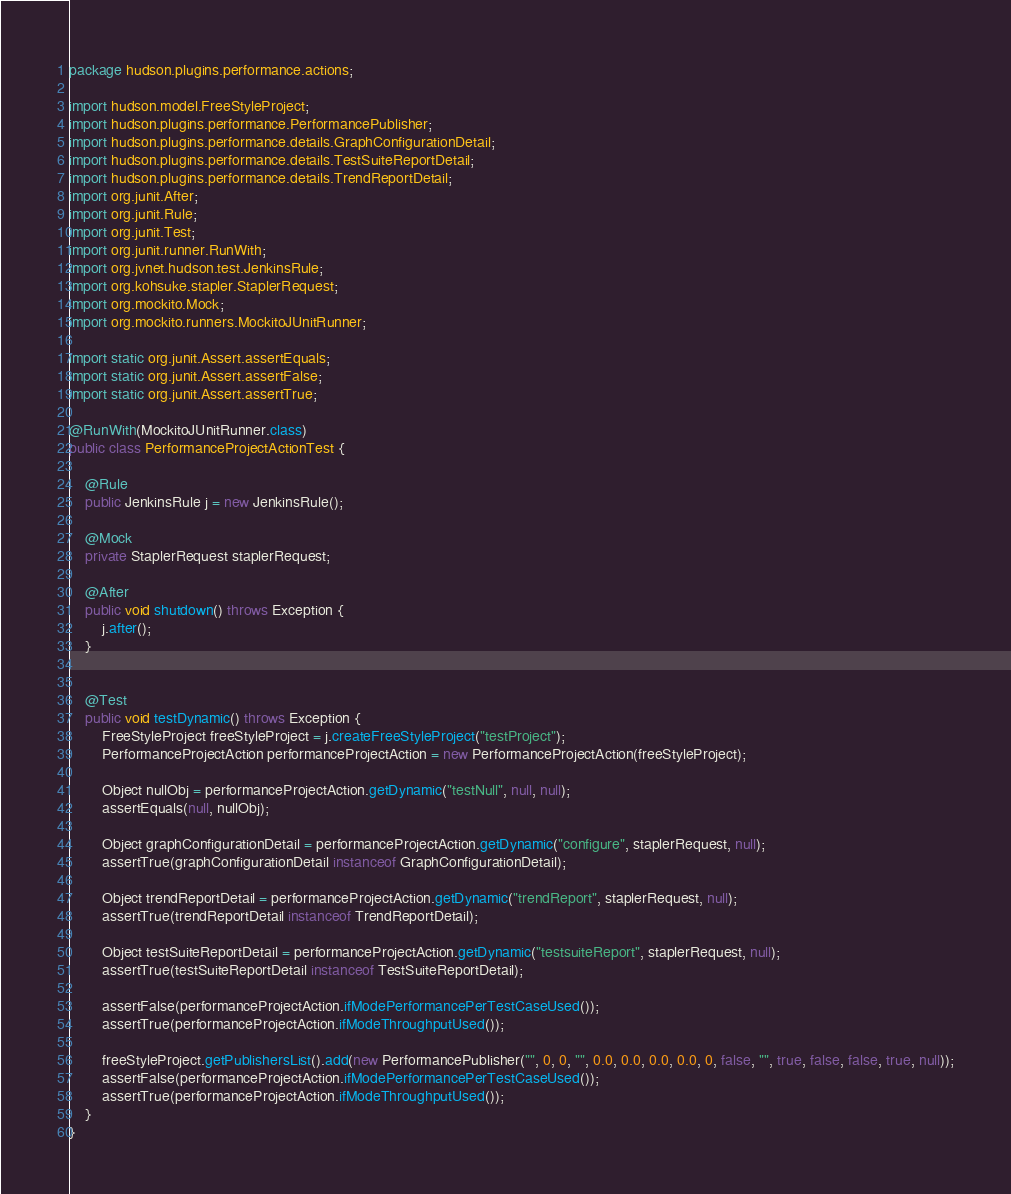<code> <loc_0><loc_0><loc_500><loc_500><_Java_>package hudson.plugins.performance.actions;

import hudson.model.FreeStyleProject;
import hudson.plugins.performance.PerformancePublisher;
import hudson.plugins.performance.details.GraphConfigurationDetail;
import hudson.plugins.performance.details.TestSuiteReportDetail;
import hudson.plugins.performance.details.TrendReportDetail;
import org.junit.After;
import org.junit.Rule;
import org.junit.Test;
import org.junit.runner.RunWith;
import org.jvnet.hudson.test.JenkinsRule;
import org.kohsuke.stapler.StaplerRequest;
import org.mockito.Mock;
import org.mockito.runners.MockitoJUnitRunner;

import static org.junit.Assert.assertEquals;
import static org.junit.Assert.assertFalse;
import static org.junit.Assert.assertTrue;

@RunWith(MockitoJUnitRunner.class)
public class PerformanceProjectActionTest {

    @Rule
    public JenkinsRule j = new JenkinsRule();

    @Mock
    private StaplerRequest staplerRequest;

    @After
    public void shutdown() throws Exception {
        j.after();
    }


    @Test
    public void testDynamic() throws Exception {
        FreeStyleProject freeStyleProject = j.createFreeStyleProject("testProject");
        PerformanceProjectAction performanceProjectAction = new PerformanceProjectAction(freeStyleProject);

        Object nullObj = performanceProjectAction.getDynamic("testNull", null, null);
        assertEquals(null, nullObj);

        Object graphConfigurationDetail = performanceProjectAction.getDynamic("configure", staplerRequest, null);
        assertTrue(graphConfigurationDetail instanceof GraphConfigurationDetail);

        Object trendReportDetail = performanceProjectAction.getDynamic("trendReport", staplerRequest, null);
        assertTrue(trendReportDetail instanceof TrendReportDetail);

        Object testSuiteReportDetail = performanceProjectAction.getDynamic("testsuiteReport", staplerRequest, null);
        assertTrue(testSuiteReportDetail instanceof TestSuiteReportDetail);

        assertFalse(performanceProjectAction.ifModePerformancePerTestCaseUsed());
        assertTrue(performanceProjectAction.ifModeThroughputUsed());

        freeStyleProject.getPublishersList().add(new PerformancePublisher("", 0, 0, "", 0.0, 0.0, 0.0, 0.0, 0, false, "", true, false, false, true, null));
        assertFalse(performanceProjectAction.ifModePerformancePerTestCaseUsed());
        assertTrue(performanceProjectAction.ifModeThroughputUsed());
    }
}</code> 